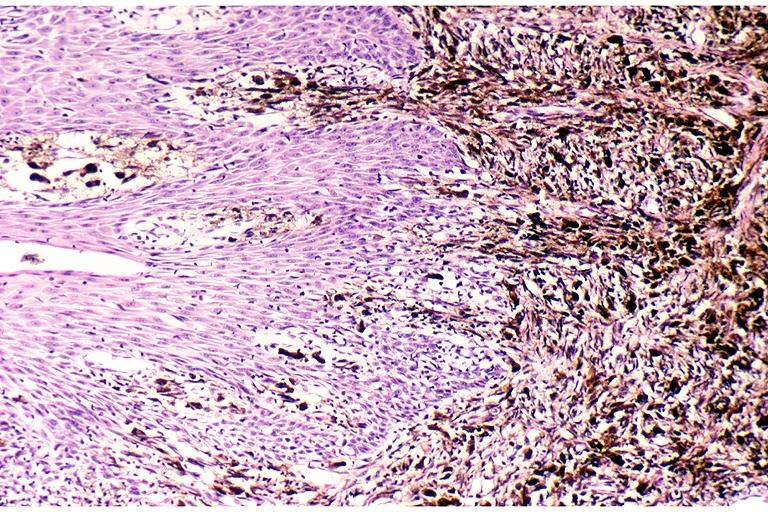where is this?
Answer the question using a single word or phrase. Oral 